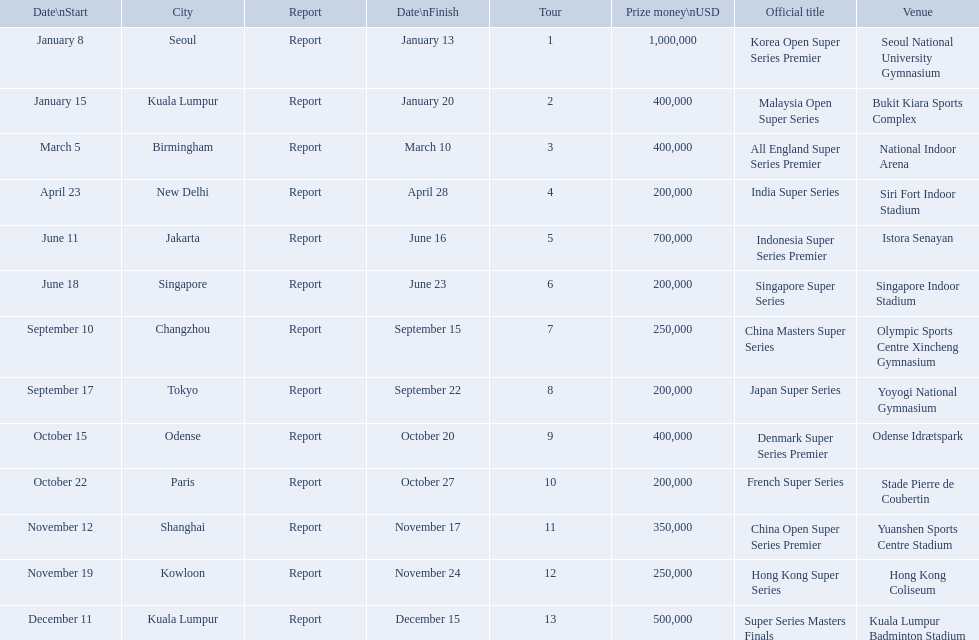What are all the tours? Korea Open Super Series Premier, Malaysia Open Super Series, All England Super Series Premier, India Super Series, Indonesia Super Series Premier, Singapore Super Series, China Masters Super Series, Japan Super Series, Denmark Super Series Premier, French Super Series, China Open Super Series Premier, Hong Kong Super Series, Super Series Masters Finals. What were the start dates of these tours? January 8, January 15, March 5, April 23, June 11, June 18, September 10, September 17, October 15, October 22, November 12, November 19, December 11. Of these, which is in december? December 11. Which tour started on this date? Super Series Masters Finals. 